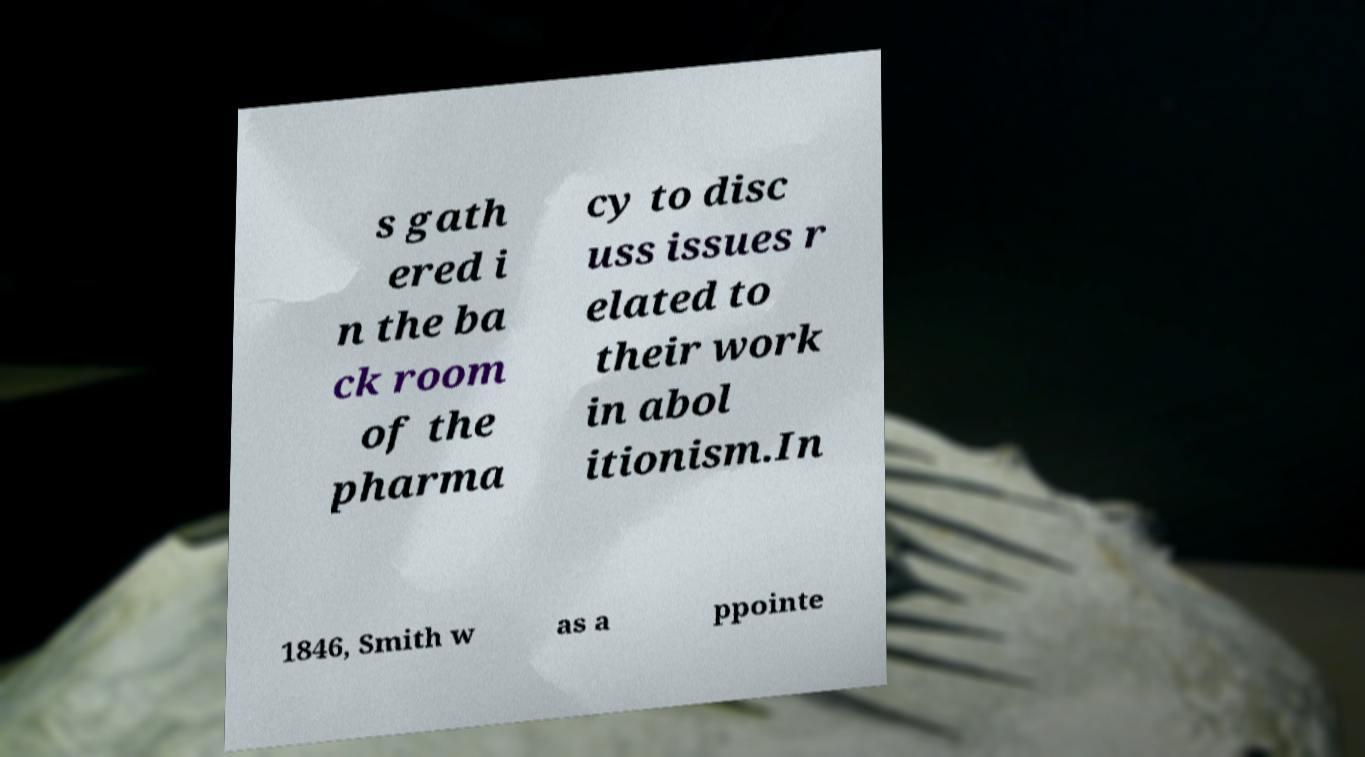Can you accurately transcribe the text from the provided image for me? s gath ered i n the ba ck room of the pharma cy to disc uss issues r elated to their work in abol itionism.In 1846, Smith w as a ppointe 